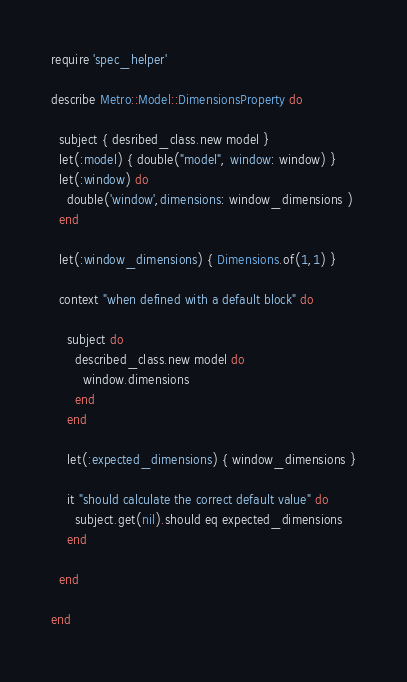<code> <loc_0><loc_0><loc_500><loc_500><_Ruby_>require 'spec_helper'

describe Metro::Model::DimensionsProperty do

  subject { desribed_class.new model }
  let(:model) { double("model", window: window) }
  let(:window) do
    double('window',dimensions: window_dimensions )
  end

  let(:window_dimensions) { Dimensions.of(1,1) }

  context "when defined with a default block" do

    subject do
      described_class.new model do
        window.dimensions
      end
    end

    let(:expected_dimensions) { window_dimensions }

    it "should calculate the correct default value" do
      subject.get(nil).should eq expected_dimensions
    end

  end

end</code> 